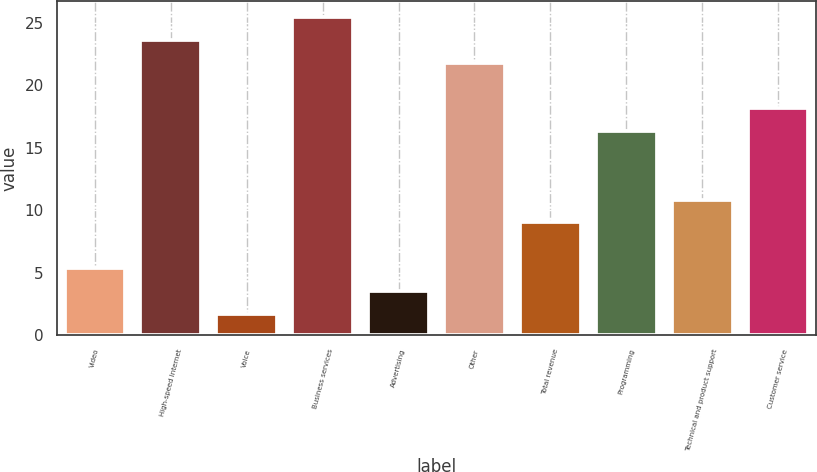Convert chart to OTSL. <chart><loc_0><loc_0><loc_500><loc_500><bar_chart><fcel>Video<fcel>High-speed Internet<fcel>Voice<fcel>Business services<fcel>Advertising<fcel>Other<fcel>Total revenue<fcel>Programming<fcel>Technical and product support<fcel>Customer service<nl><fcel>5.36<fcel>23.66<fcel>1.7<fcel>25.49<fcel>3.53<fcel>21.83<fcel>9.02<fcel>16.34<fcel>10.85<fcel>18.17<nl></chart> 